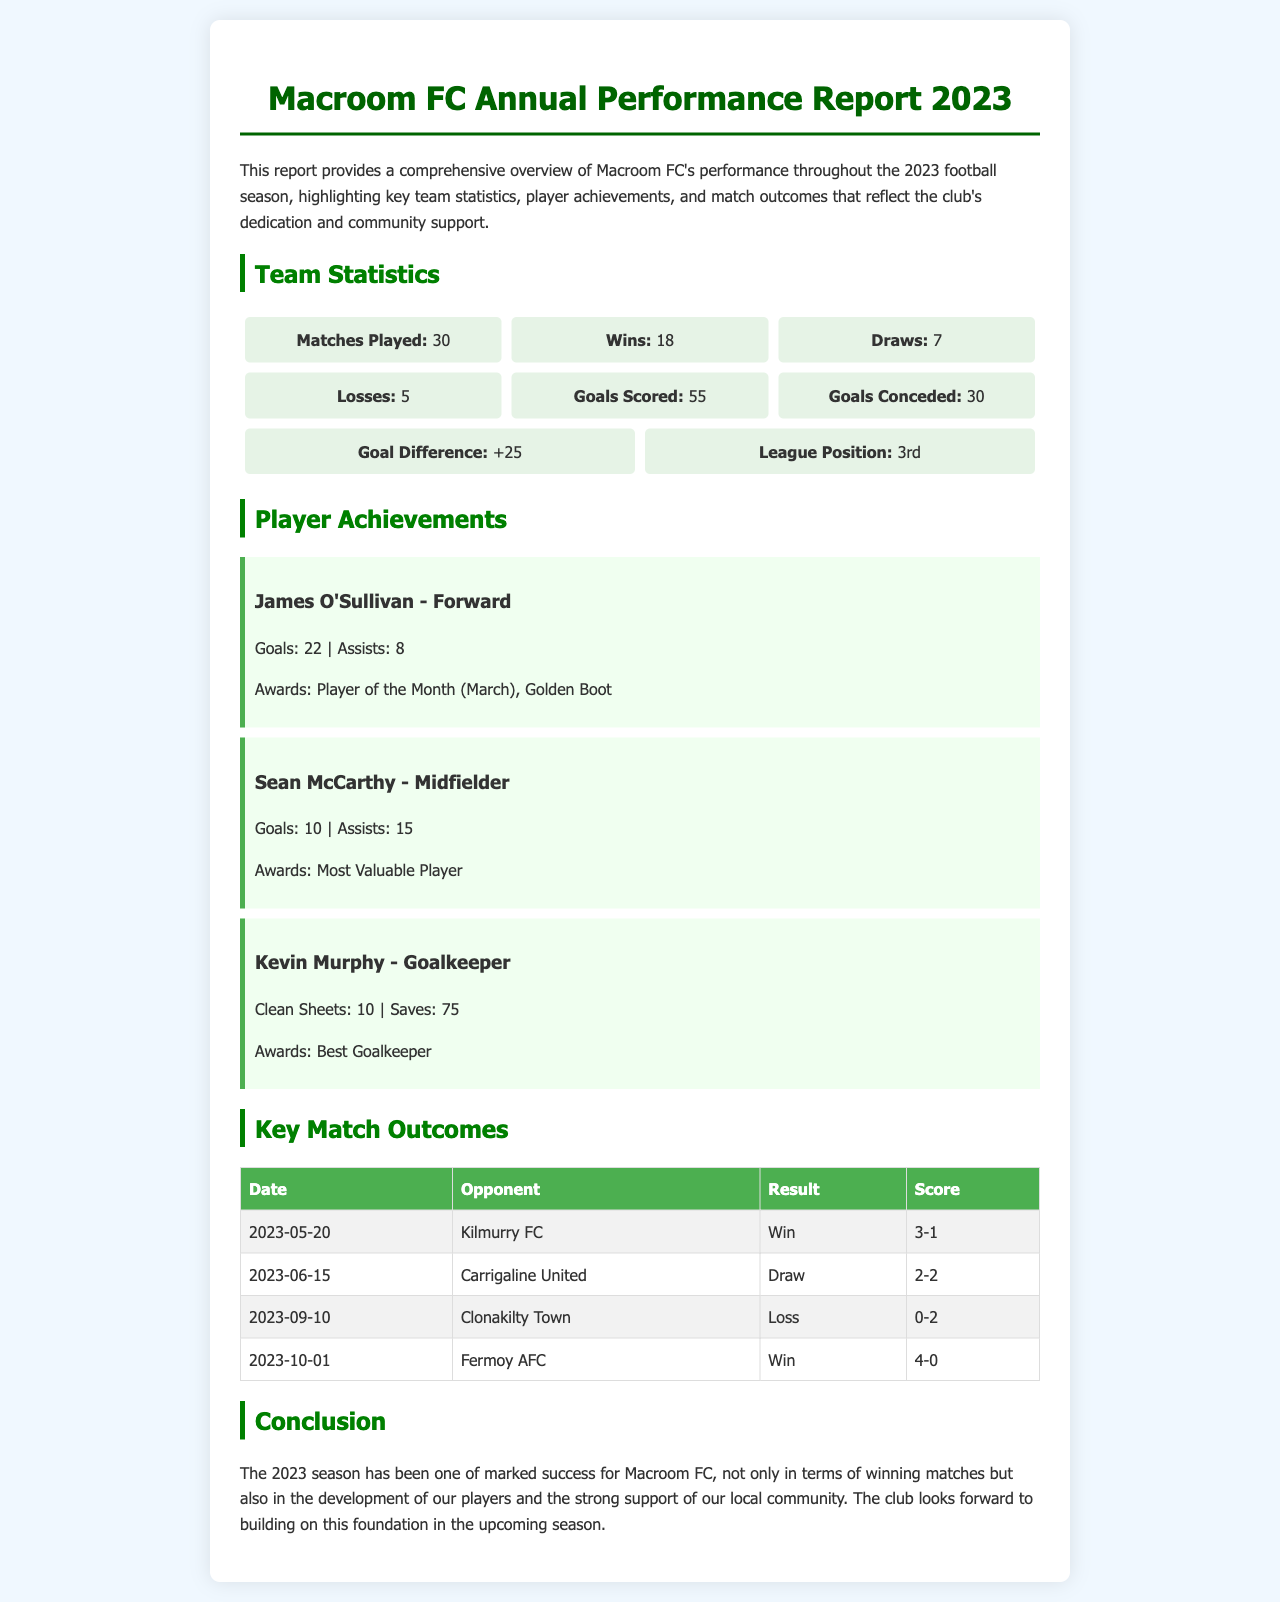What is the total number of matches played? The total number of matches played is stated in the Team Statistics section as 30.
Answer: 30 Who is Macroom FC's top scorer? The player with the most goals, listed in Player Achievements, is James O'Sullivan with 22 goals.
Answer: James O'Sullivan How many assists did Sean McCarthy make? Sean McCarthy's assists are specified in Player Achievements as 15.
Answer: 15 What was Macroom FC's league position at the end of the season? The league position is indicated in the Team Statistics as 3rd.
Answer: 3rd What was the score in the match against Fermoy AFC? The score against Fermoy AFC, found in the Key Match Outcomes table, was 4-0.
Answer: 4-0 What award did Kevin Murphy receive? Kevin Murphy received the Best Goalkeeper award as mentioned in Player Achievements.
Answer: Best Goalkeeper How many goals did Macroom FC concede during the season? The total goals conceded is mentioned in the Team Statistics as 30.
Answer: 30 Which match resulted in a loss for Macroom FC? The match against Clonakilty Town is specified in the Key Match Outcomes table as a loss with a score of 0-2.
Answer: Clonakilty Town How many goals did the team score throughout the season? The total goals scored is provided in the Team Statistics section as 55.
Answer: 55 